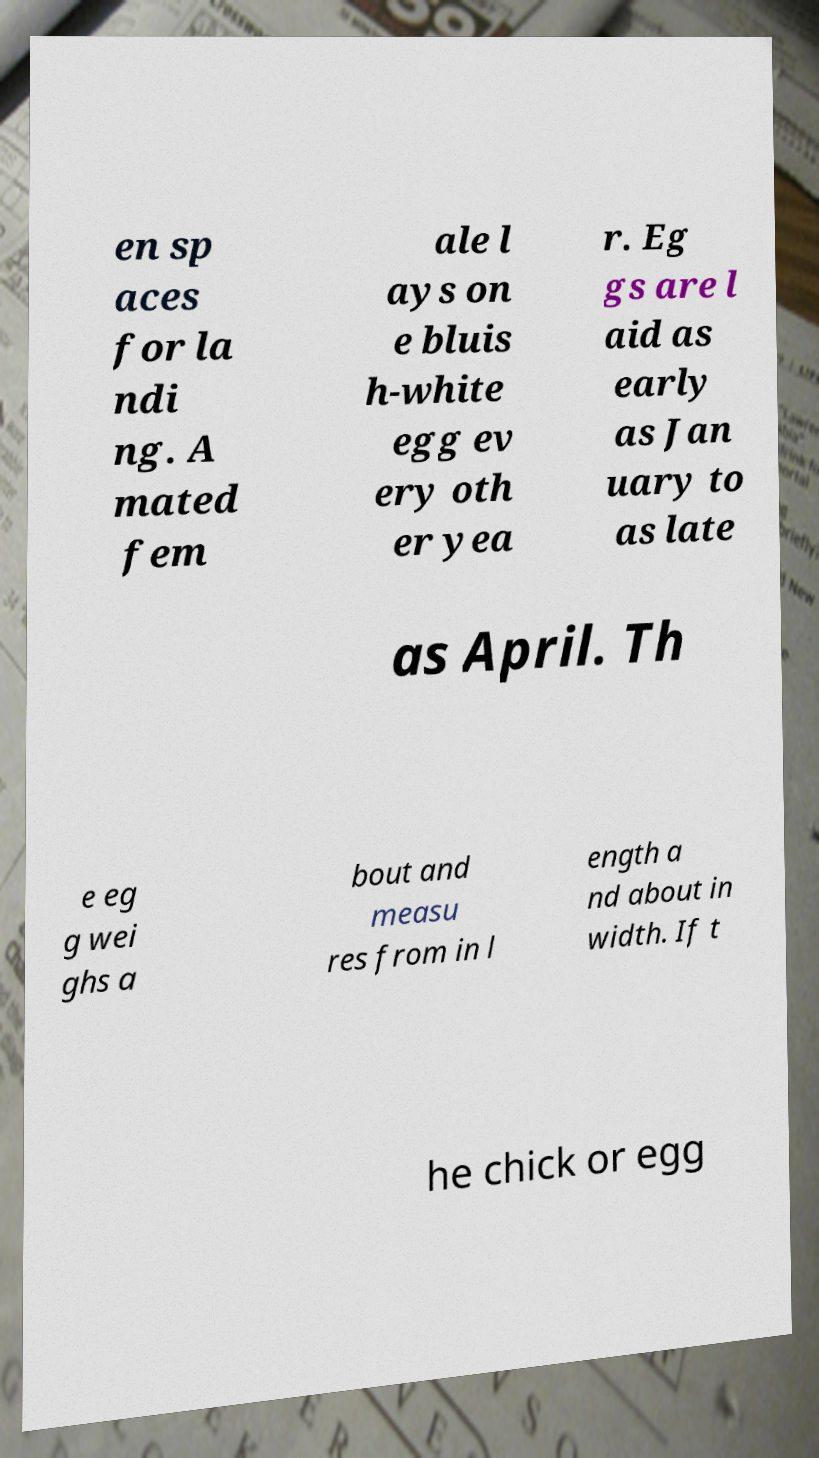Can you accurately transcribe the text from the provided image for me? en sp aces for la ndi ng. A mated fem ale l ays on e bluis h-white egg ev ery oth er yea r. Eg gs are l aid as early as Jan uary to as late as April. Th e eg g wei ghs a bout and measu res from in l ength a nd about in width. If t he chick or egg 